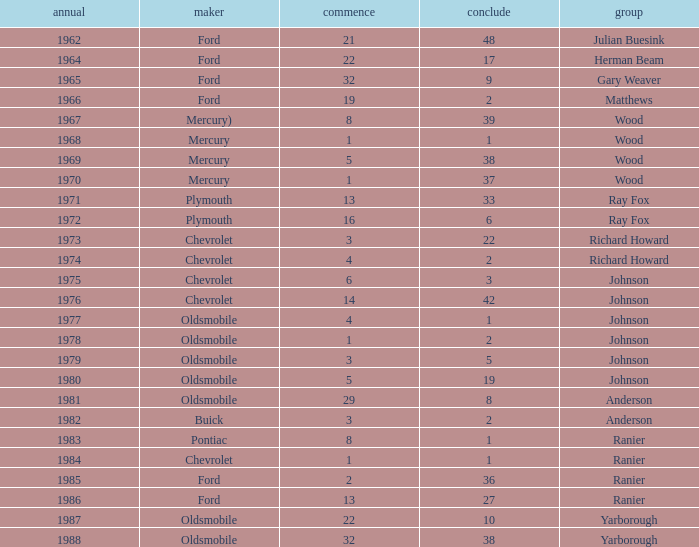Who was the maufacturer of the vehicle during the race where Cale Yarborough started at 19 and finished earlier than 42? Ford. 